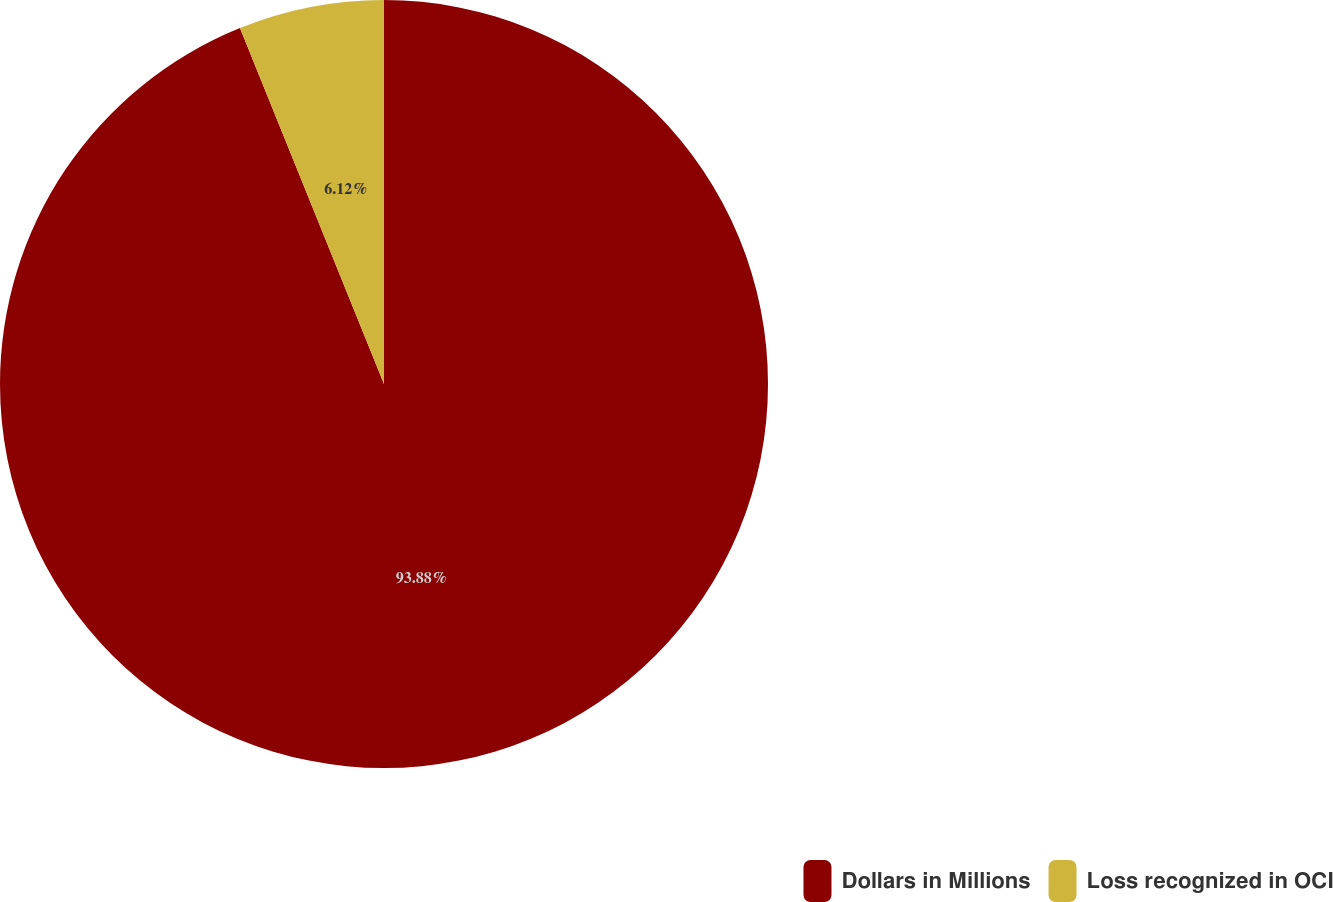<chart> <loc_0><loc_0><loc_500><loc_500><pie_chart><fcel>Dollars in Millions<fcel>Loss recognized in OCI<nl><fcel>93.88%<fcel>6.12%<nl></chart> 